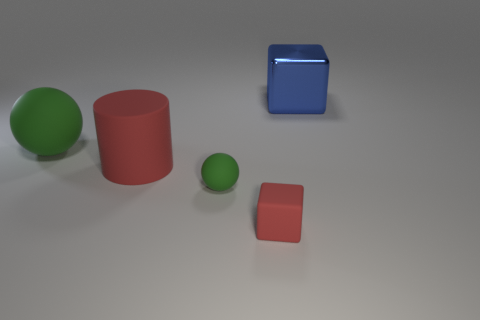There is a red object that is the same shape as the large blue thing; what is its size?
Your answer should be compact. Small. How big is the red rubber thing that is behind the red matte block?
Ensure brevity in your answer.  Large. Is the number of large spheres in front of the large cylinder greater than the number of green cylinders?
Keep it short and to the point. No. What is the shape of the small red object?
Ensure brevity in your answer.  Cube. There is a cube that is left of the blue cube; does it have the same color as the large object that is on the right side of the small green object?
Ensure brevity in your answer.  No. Is the shape of the blue shiny thing the same as the small red object?
Offer a very short reply. Yes. Are there any other things that are the same shape as the blue metallic thing?
Offer a terse response. Yes. Are the cube to the left of the blue metallic thing and the large blue object made of the same material?
Provide a short and direct response. No. What is the shape of the matte thing that is behind the tiny rubber sphere and on the right side of the big green object?
Provide a short and direct response. Cylinder. There is a green ball that is to the left of the tiny ball; is there a red matte cube that is behind it?
Offer a terse response. No. 